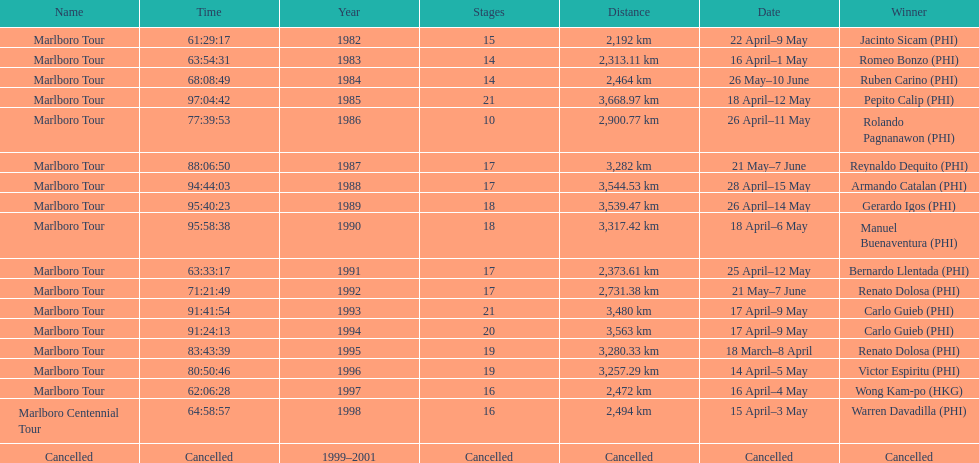How many marlboro tours did carlo guieb win? 2. 